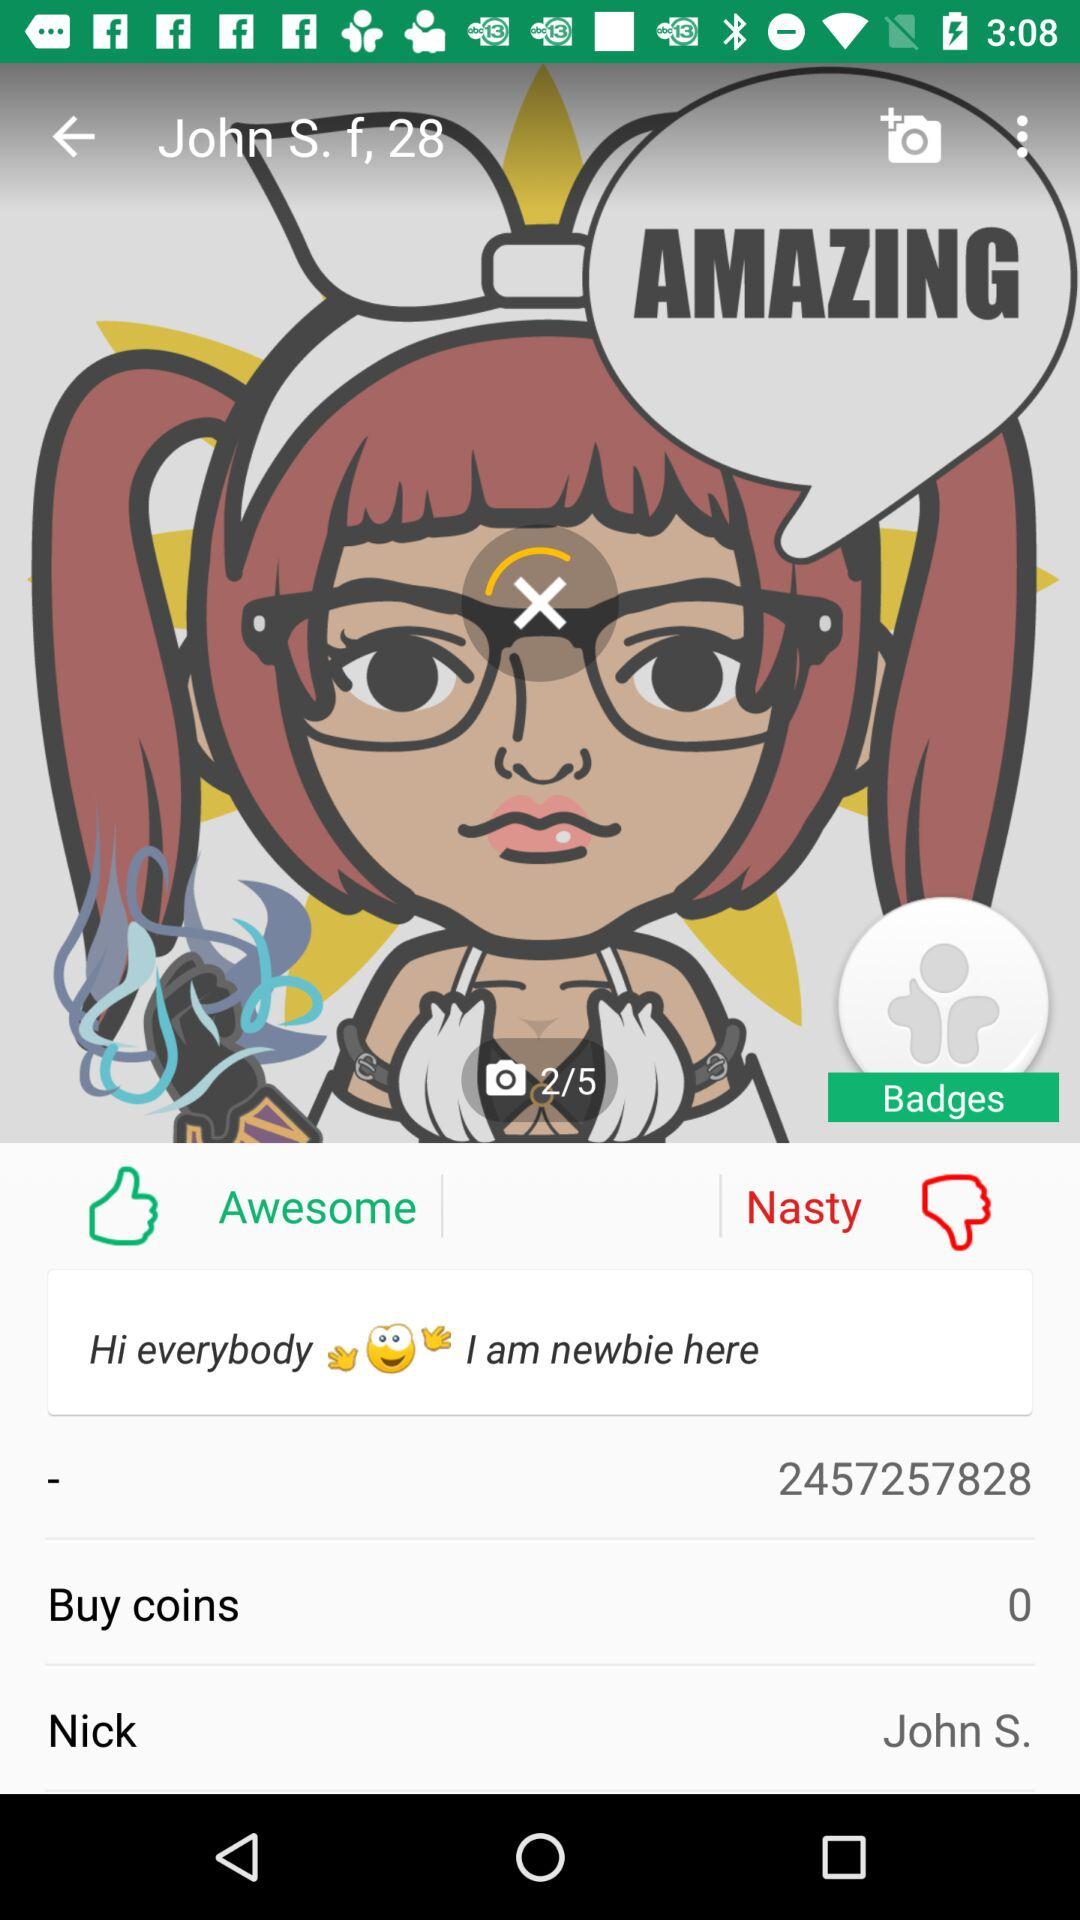What is the name of the user? The name of the user is John S. 